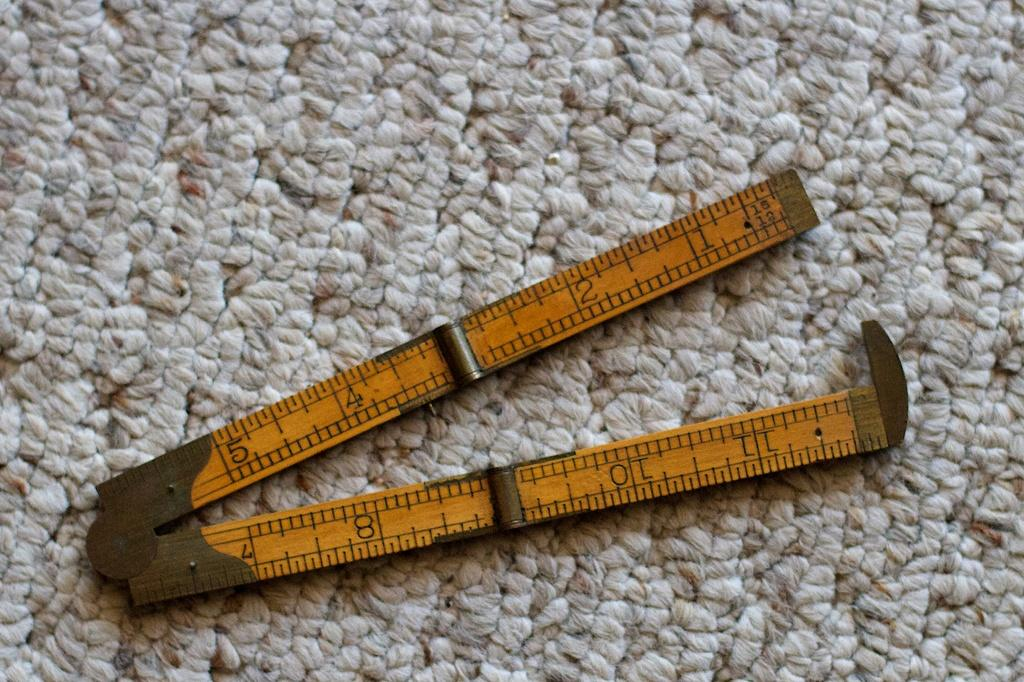<image>
Offer a succinct explanation of the picture presented. An old compass with the numbers 1 through 11 on it. 